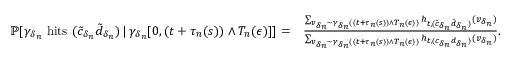<formula> <loc_0><loc_0><loc_500><loc_500>\begin{array} { r l } { \mathbb { P } [ \gamma _ { \delta _ { n } } h i t s ( \tilde { c } _ { \delta _ { n } } \tilde { d } _ { \delta _ { n } } ) \, | \, \gamma _ { \delta _ { n } } [ 0 , ( t + \tau _ { n } ( s ) ) \wedge T _ { n } ( \epsilon ) ] ] = } & { \frac { \sum _ { v _ { \delta _ { n } } \sim \gamma _ { \delta _ { n } } ( ( t + \tau _ { n } ( s ) ) \wedge T _ { n } ( \epsilon ) ) } h _ { t , ( \tilde { c } _ { \delta _ { n } } \tilde { d } _ { \delta _ { n } } ) } ( v _ { \delta _ { n } } ) } { \sum _ { v _ { \delta _ { n } } \sim \gamma _ { \delta _ { n } } ( ( t + \tau _ { n } ( s ) ) \wedge T _ { n } ( \epsilon ) ) } h _ { t , ( c _ { \delta _ { n } } d _ { \delta _ { n } } ) } ( v _ { \delta _ { n } } ) } . } \end{array}</formula> 